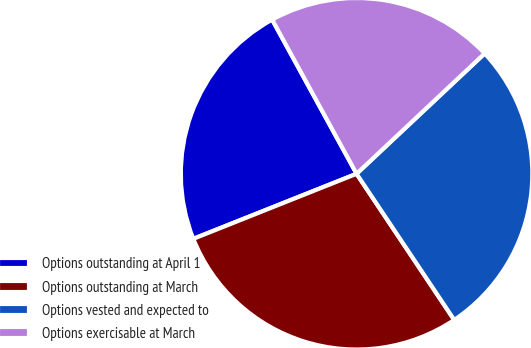<chart> <loc_0><loc_0><loc_500><loc_500><pie_chart><fcel>Options outstanding at April 1<fcel>Options outstanding at March<fcel>Options vested and expected to<fcel>Options exercisable at March<nl><fcel>23.06%<fcel>28.34%<fcel>27.63%<fcel>20.97%<nl></chart> 